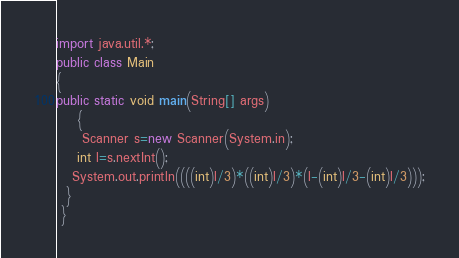Convert code to text. <code><loc_0><loc_0><loc_500><loc_500><_Java_>import java.util.*;
public class Main
{
public static void main(String[] args)
    { 
     Scanner s=new Scanner(System.in);
    int l=s.nextInt();
   System.out.println((((int)l/3)*((int)l/3)*(l-(int)l/3-(int)l/3)));
  }
 }</code> 